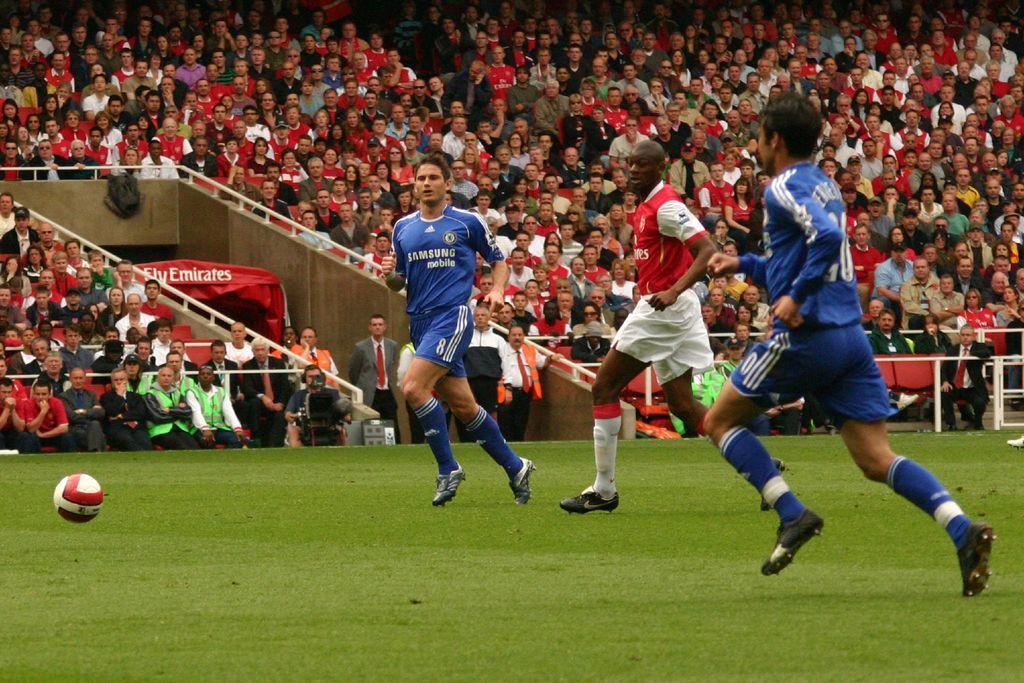Describe this image in one or two sentences. In this image there are three players playing soccer in the field, in front of them there are spectators watching the game from the stands. 